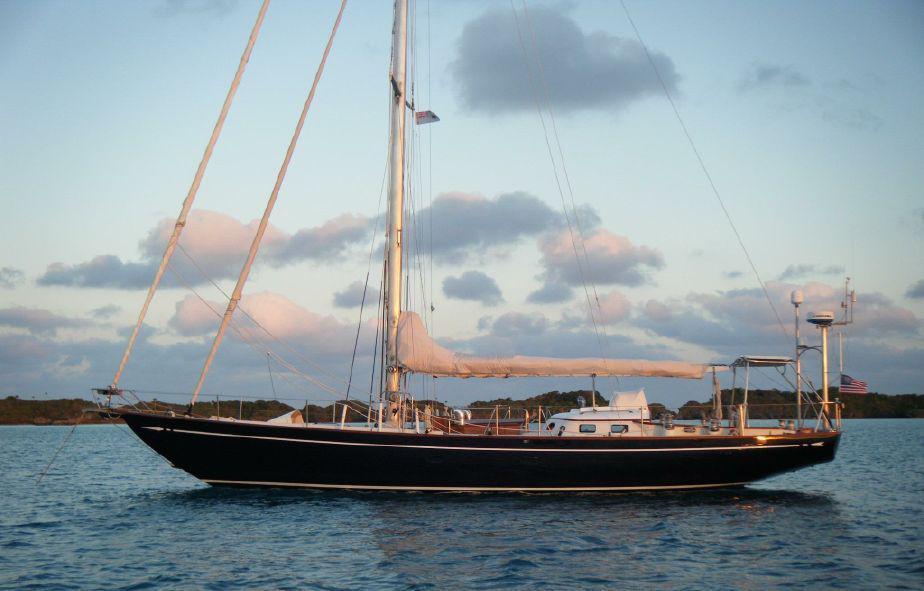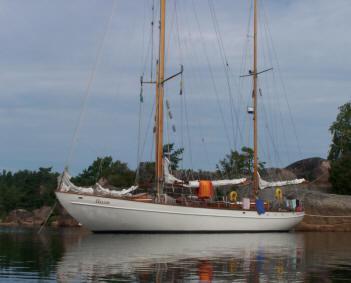The first image is the image on the left, the second image is the image on the right. Considering the images on both sides, is "One sailboat is sitting on a platform on dry land, while a second sailboat is floating on water." valid? Answer yes or no. No. The first image is the image on the left, the second image is the image on the right. Examine the images to the left and right. Is the description "The left and right image contains the same number of sailboats with there sails down." accurate? Answer yes or no. Yes. 